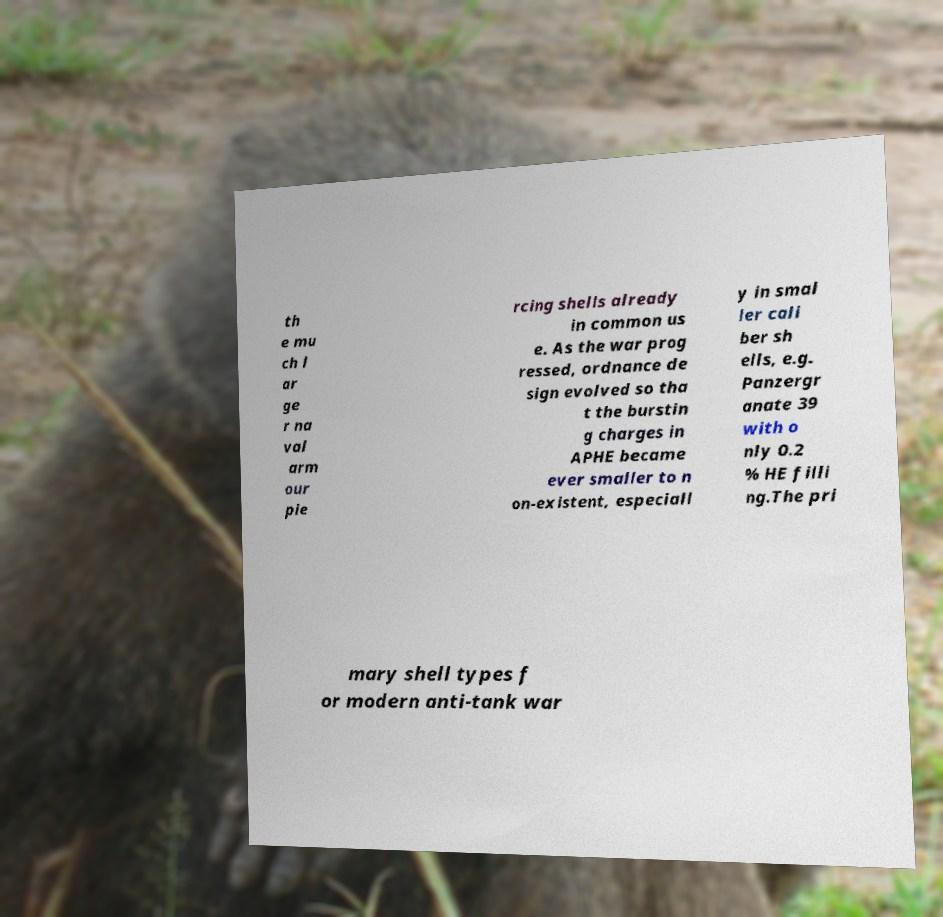There's text embedded in this image that I need extracted. Can you transcribe it verbatim? th e mu ch l ar ge r na val arm our pie rcing shells already in common us e. As the war prog ressed, ordnance de sign evolved so tha t the burstin g charges in APHE became ever smaller to n on-existent, especiall y in smal ler cali ber sh ells, e.g. Panzergr anate 39 with o nly 0.2 % HE filli ng.The pri mary shell types f or modern anti-tank war 